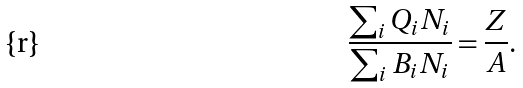<formula> <loc_0><loc_0><loc_500><loc_500>\frac { \sum _ { i } Q _ { i } N _ { i } } { \sum _ { i } B _ { i } N _ { i } } = \frac { Z } { A } .</formula> 